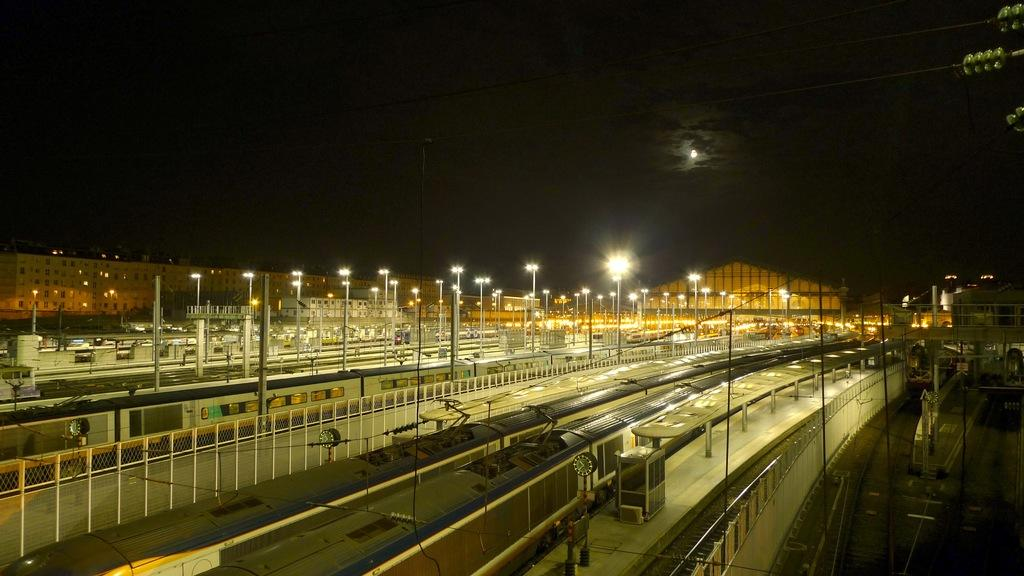What type of vehicles can be seen in the image? There are trains in the image. What is the purpose of the fence in the image? The fence is likely used to separate areas or provide security. What are the lights on poles used for in the image? The lights on poles are likely used for illumination, especially at night. What structures are present for passengers to wait or board the trains? There are platforms in the image for passengers to wait or board the trains. What else can be seen in the image besides the trains and platforms? There are wires, a fence, lights on poles, buildings in the background, and the sky visible in the background of the image. Can you tell me how many beads are hanging from the train in the image? There are no beads present in the image; it features trains, a fence, lights on poles, platforms, wires, buildings, and the sky. 